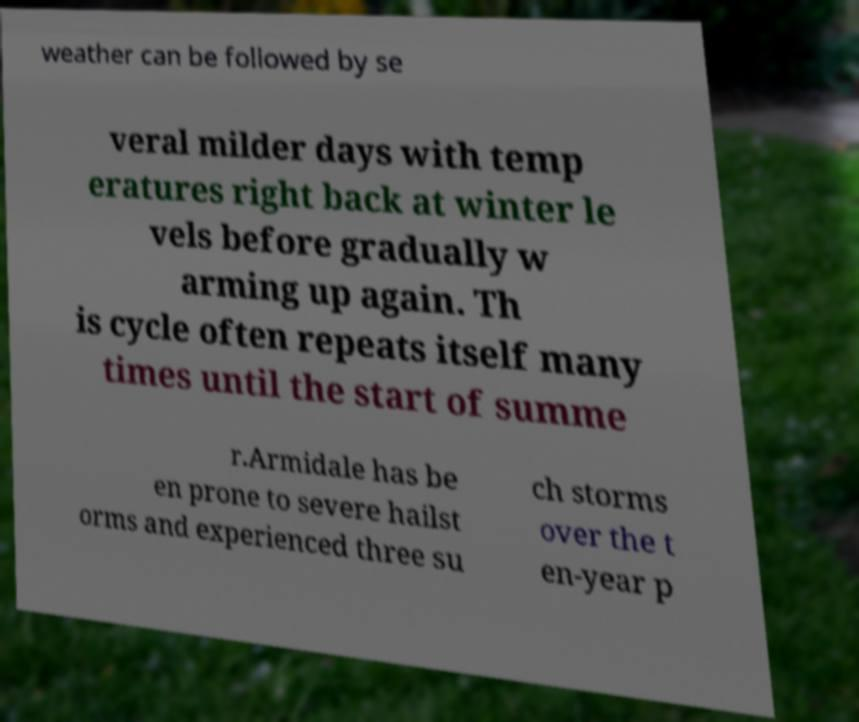Please identify and transcribe the text found in this image. weather can be followed by se veral milder days with temp eratures right back at winter le vels before gradually w arming up again. Th is cycle often repeats itself many times until the start of summe r.Armidale has be en prone to severe hailst orms and experienced three su ch storms over the t en-year p 